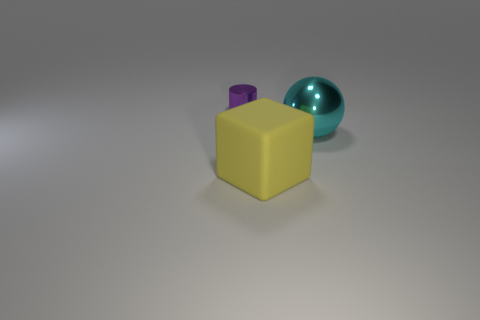Add 3 big brown matte balls. How many objects exist? 6 Subtract 0 gray spheres. How many objects are left? 3 Subtract all cubes. How many objects are left? 2 Subtract all gray cylinders. Subtract all red balls. How many cylinders are left? 1 Subtract all big green shiny blocks. Subtract all purple shiny cylinders. How many objects are left? 2 Add 3 big yellow rubber blocks. How many big yellow rubber blocks are left? 4 Add 1 shiny balls. How many shiny balls exist? 2 